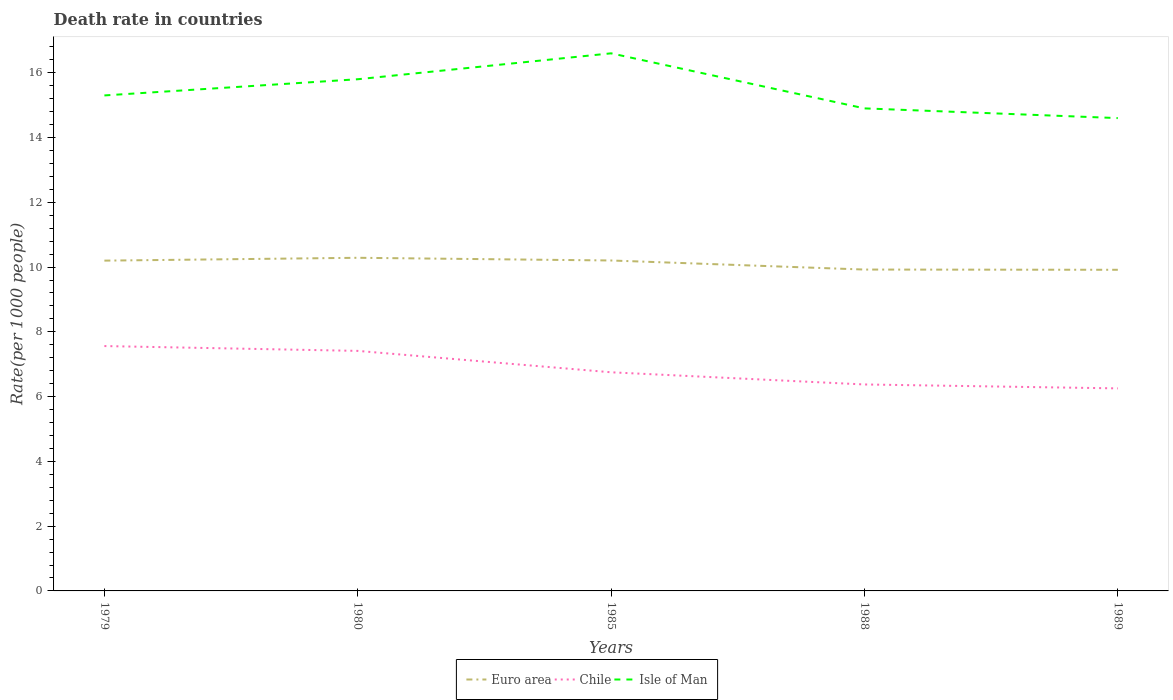How many different coloured lines are there?
Provide a short and direct response. 3. Does the line corresponding to Chile intersect with the line corresponding to Isle of Man?
Provide a succinct answer. No. In which year was the death rate in Euro area maximum?
Make the answer very short. 1989. What is the total death rate in Chile in the graph?
Ensure brevity in your answer.  1.04. What is the difference between the highest and the second highest death rate in Chile?
Your response must be concise. 1.31. What is the difference between two consecutive major ticks on the Y-axis?
Offer a very short reply. 2. Does the graph contain any zero values?
Provide a succinct answer. No. Does the graph contain grids?
Make the answer very short. No. Where does the legend appear in the graph?
Ensure brevity in your answer.  Bottom center. How are the legend labels stacked?
Your answer should be very brief. Horizontal. What is the title of the graph?
Give a very brief answer. Death rate in countries. Does "World" appear as one of the legend labels in the graph?
Give a very brief answer. No. What is the label or title of the X-axis?
Provide a short and direct response. Years. What is the label or title of the Y-axis?
Your answer should be compact. Rate(per 1000 people). What is the Rate(per 1000 people) of Euro area in 1979?
Offer a very short reply. 10.2. What is the Rate(per 1000 people) of Chile in 1979?
Your answer should be very brief. 7.56. What is the Rate(per 1000 people) in Isle of Man in 1979?
Provide a succinct answer. 15.3. What is the Rate(per 1000 people) in Euro area in 1980?
Keep it short and to the point. 10.29. What is the Rate(per 1000 people) in Chile in 1980?
Your answer should be compact. 7.41. What is the Rate(per 1000 people) of Isle of Man in 1980?
Provide a short and direct response. 15.8. What is the Rate(per 1000 people) of Euro area in 1985?
Keep it short and to the point. 10.2. What is the Rate(per 1000 people) in Chile in 1985?
Your response must be concise. 6.75. What is the Rate(per 1000 people) of Euro area in 1988?
Give a very brief answer. 9.92. What is the Rate(per 1000 people) of Chile in 1988?
Offer a very short reply. 6.38. What is the Rate(per 1000 people) of Isle of Man in 1988?
Keep it short and to the point. 14.9. What is the Rate(per 1000 people) in Euro area in 1989?
Give a very brief answer. 9.92. What is the Rate(per 1000 people) in Chile in 1989?
Provide a succinct answer. 6.25. Across all years, what is the maximum Rate(per 1000 people) of Euro area?
Provide a succinct answer. 10.29. Across all years, what is the maximum Rate(per 1000 people) in Chile?
Your answer should be compact. 7.56. Across all years, what is the maximum Rate(per 1000 people) of Isle of Man?
Offer a very short reply. 16.6. Across all years, what is the minimum Rate(per 1000 people) in Euro area?
Offer a terse response. 9.92. Across all years, what is the minimum Rate(per 1000 people) of Chile?
Your answer should be very brief. 6.25. Across all years, what is the minimum Rate(per 1000 people) in Isle of Man?
Keep it short and to the point. 14.6. What is the total Rate(per 1000 people) in Euro area in the graph?
Provide a succinct answer. 50.53. What is the total Rate(per 1000 people) in Chile in the graph?
Your answer should be very brief. 34.35. What is the total Rate(per 1000 people) of Isle of Man in the graph?
Offer a terse response. 77.2. What is the difference between the Rate(per 1000 people) in Euro area in 1979 and that in 1980?
Ensure brevity in your answer.  -0.09. What is the difference between the Rate(per 1000 people) in Chile in 1979 and that in 1980?
Ensure brevity in your answer.  0.15. What is the difference between the Rate(per 1000 people) in Euro area in 1979 and that in 1985?
Your answer should be very brief. -0. What is the difference between the Rate(per 1000 people) of Chile in 1979 and that in 1985?
Provide a succinct answer. 0.81. What is the difference between the Rate(per 1000 people) in Isle of Man in 1979 and that in 1985?
Your answer should be compact. -1.3. What is the difference between the Rate(per 1000 people) in Euro area in 1979 and that in 1988?
Offer a terse response. 0.28. What is the difference between the Rate(per 1000 people) in Chile in 1979 and that in 1988?
Ensure brevity in your answer.  1.19. What is the difference between the Rate(per 1000 people) in Euro area in 1979 and that in 1989?
Provide a succinct answer. 0.28. What is the difference between the Rate(per 1000 people) of Chile in 1979 and that in 1989?
Your answer should be compact. 1.31. What is the difference between the Rate(per 1000 people) in Isle of Man in 1979 and that in 1989?
Offer a terse response. 0.7. What is the difference between the Rate(per 1000 people) of Euro area in 1980 and that in 1985?
Give a very brief answer. 0.08. What is the difference between the Rate(per 1000 people) of Chile in 1980 and that in 1985?
Offer a terse response. 0.66. What is the difference between the Rate(per 1000 people) of Isle of Man in 1980 and that in 1985?
Your answer should be very brief. -0.8. What is the difference between the Rate(per 1000 people) in Euro area in 1980 and that in 1988?
Your answer should be very brief. 0.36. What is the difference between the Rate(per 1000 people) in Chile in 1980 and that in 1988?
Give a very brief answer. 1.04. What is the difference between the Rate(per 1000 people) in Euro area in 1980 and that in 1989?
Your response must be concise. 0.37. What is the difference between the Rate(per 1000 people) of Chile in 1980 and that in 1989?
Your answer should be very brief. 1.16. What is the difference between the Rate(per 1000 people) of Isle of Man in 1980 and that in 1989?
Offer a very short reply. 1.2. What is the difference between the Rate(per 1000 people) in Euro area in 1985 and that in 1988?
Offer a very short reply. 0.28. What is the difference between the Rate(per 1000 people) of Chile in 1985 and that in 1988?
Give a very brief answer. 0.38. What is the difference between the Rate(per 1000 people) of Euro area in 1985 and that in 1989?
Offer a terse response. 0.29. What is the difference between the Rate(per 1000 people) of Chile in 1985 and that in 1989?
Keep it short and to the point. 0.5. What is the difference between the Rate(per 1000 people) of Isle of Man in 1985 and that in 1989?
Provide a succinct answer. 2. What is the difference between the Rate(per 1000 people) of Euro area in 1988 and that in 1989?
Offer a terse response. 0.01. What is the difference between the Rate(per 1000 people) of Chile in 1988 and that in 1989?
Provide a short and direct response. 0.12. What is the difference between the Rate(per 1000 people) of Isle of Man in 1988 and that in 1989?
Provide a succinct answer. 0.3. What is the difference between the Rate(per 1000 people) in Euro area in 1979 and the Rate(per 1000 people) in Chile in 1980?
Keep it short and to the point. 2.79. What is the difference between the Rate(per 1000 people) of Euro area in 1979 and the Rate(per 1000 people) of Isle of Man in 1980?
Keep it short and to the point. -5.6. What is the difference between the Rate(per 1000 people) in Chile in 1979 and the Rate(per 1000 people) in Isle of Man in 1980?
Your answer should be very brief. -8.24. What is the difference between the Rate(per 1000 people) in Euro area in 1979 and the Rate(per 1000 people) in Chile in 1985?
Your answer should be very brief. 3.45. What is the difference between the Rate(per 1000 people) of Euro area in 1979 and the Rate(per 1000 people) of Isle of Man in 1985?
Provide a short and direct response. -6.4. What is the difference between the Rate(per 1000 people) in Chile in 1979 and the Rate(per 1000 people) in Isle of Man in 1985?
Keep it short and to the point. -9.04. What is the difference between the Rate(per 1000 people) in Euro area in 1979 and the Rate(per 1000 people) in Chile in 1988?
Your response must be concise. 3.82. What is the difference between the Rate(per 1000 people) in Euro area in 1979 and the Rate(per 1000 people) in Isle of Man in 1988?
Keep it short and to the point. -4.7. What is the difference between the Rate(per 1000 people) of Chile in 1979 and the Rate(per 1000 people) of Isle of Man in 1988?
Provide a short and direct response. -7.34. What is the difference between the Rate(per 1000 people) of Euro area in 1979 and the Rate(per 1000 people) of Chile in 1989?
Provide a succinct answer. 3.94. What is the difference between the Rate(per 1000 people) of Euro area in 1979 and the Rate(per 1000 people) of Isle of Man in 1989?
Offer a very short reply. -4.4. What is the difference between the Rate(per 1000 people) in Chile in 1979 and the Rate(per 1000 people) in Isle of Man in 1989?
Your answer should be compact. -7.04. What is the difference between the Rate(per 1000 people) in Euro area in 1980 and the Rate(per 1000 people) in Chile in 1985?
Your response must be concise. 3.54. What is the difference between the Rate(per 1000 people) in Euro area in 1980 and the Rate(per 1000 people) in Isle of Man in 1985?
Ensure brevity in your answer.  -6.31. What is the difference between the Rate(per 1000 people) in Chile in 1980 and the Rate(per 1000 people) in Isle of Man in 1985?
Your answer should be very brief. -9.19. What is the difference between the Rate(per 1000 people) of Euro area in 1980 and the Rate(per 1000 people) of Chile in 1988?
Your answer should be compact. 3.91. What is the difference between the Rate(per 1000 people) in Euro area in 1980 and the Rate(per 1000 people) in Isle of Man in 1988?
Your answer should be compact. -4.61. What is the difference between the Rate(per 1000 people) of Chile in 1980 and the Rate(per 1000 people) of Isle of Man in 1988?
Your answer should be very brief. -7.49. What is the difference between the Rate(per 1000 people) in Euro area in 1980 and the Rate(per 1000 people) in Chile in 1989?
Provide a succinct answer. 4.03. What is the difference between the Rate(per 1000 people) in Euro area in 1980 and the Rate(per 1000 people) in Isle of Man in 1989?
Keep it short and to the point. -4.31. What is the difference between the Rate(per 1000 people) of Chile in 1980 and the Rate(per 1000 people) of Isle of Man in 1989?
Provide a short and direct response. -7.19. What is the difference between the Rate(per 1000 people) of Euro area in 1985 and the Rate(per 1000 people) of Chile in 1988?
Your response must be concise. 3.83. What is the difference between the Rate(per 1000 people) in Euro area in 1985 and the Rate(per 1000 people) in Isle of Man in 1988?
Keep it short and to the point. -4.7. What is the difference between the Rate(per 1000 people) in Chile in 1985 and the Rate(per 1000 people) in Isle of Man in 1988?
Provide a short and direct response. -8.15. What is the difference between the Rate(per 1000 people) in Euro area in 1985 and the Rate(per 1000 people) in Chile in 1989?
Make the answer very short. 3.95. What is the difference between the Rate(per 1000 people) in Euro area in 1985 and the Rate(per 1000 people) in Isle of Man in 1989?
Keep it short and to the point. -4.4. What is the difference between the Rate(per 1000 people) of Chile in 1985 and the Rate(per 1000 people) of Isle of Man in 1989?
Provide a short and direct response. -7.85. What is the difference between the Rate(per 1000 people) of Euro area in 1988 and the Rate(per 1000 people) of Chile in 1989?
Offer a very short reply. 3.67. What is the difference between the Rate(per 1000 people) of Euro area in 1988 and the Rate(per 1000 people) of Isle of Man in 1989?
Keep it short and to the point. -4.68. What is the difference between the Rate(per 1000 people) of Chile in 1988 and the Rate(per 1000 people) of Isle of Man in 1989?
Keep it short and to the point. -8.22. What is the average Rate(per 1000 people) in Euro area per year?
Provide a succinct answer. 10.11. What is the average Rate(per 1000 people) of Chile per year?
Your response must be concise. 6.87. What is the average Rate(per 1000 people) in Isle of Man per year?
Offer a terse response. 15.44. In the year 1979, what is the difference between the Rate(per 1000 people) of Euro area and Rate(per 1000 people) of Chile?
Your answer should be very brief. 2.64. In the year 1979, what is the difference between the Rate(per 1000 people) in Euro area and Rate(per 1000 people) in Isle of Man?
Provide a succinct answer. -5.1. In the year 1979, what is the difference between the Rate(per 1000 people) of Chile and Rate(per 1000 people) of Isle of Man?
Your response must be concise. -7.74. In the year 1980, what is the difference between the Rate(per 1000 people) of Euro area and Rate(per 1000 people) of Chile?
Provide a succinct answer. 2.87. In the year 1980, what is the difference between the Rate(per 1000 people) in Euro area and Rate(per 1000 people) in Isle of Man?
Keep it short and to the point. -5.51. In the year 1980, what is the difference between the Rate(per 1000 people) of Chile and Rate(per 1000 people) of Isle of Man?
Make the answer very short. -8.39. In the year 1985, what is the difference between the Rate(per 1000 people) in Euro area and Rate(per 1000 people) in Chile?
Offer a very short reply. 3.45. In the year 1985, what is the difference between the Rate(per 1000 people) of Euro area and Rate(per 1000 people) of Isle of Man?
Make the answer very short. -6.4. In the year 1985, what is the difference between the Rate(per 1000 people) in Chile and Rate(per 1000 people) in Isle of Man?
Provide a succinct answer. -9.85. In the year 1988, what is the difference between the Rate(per 1000 people) of Euro area and Rate(per 1000 people) of Chile?
Provide a succinct answer. 3.55. In the year 1988, what is the difference between the Rate(per 1000 people) of Euro area and Rate(per 1000 people) of Isle of Man?
Offer a very short reply. -4.98. In the year 1988, what is the difference between the Rate(per 1000 people) of Chile and Rate(per 1000 people) of Isle of Man?
Your answer should be very brief. -8.53. In the year 1989, what is the difference between the Rate(per 1000 people) in Euro area and Rate(per 1000 people) in Chile?
Offer a terse response. 3.66. In the year 1989, what is the difference between the Rate(per 1000 people) of Euro area and Rate(per 1000 people) of Isle of Man?
Provide a succinct answer. -4.68. In the year 1989, what is the difference between the Rate(per 1000 people) in Chile and Rate(per 1000 people) in Isle of Man?
Make the answer very short. -8.35. What is the ratio of the Rate(per 1000 people) in Euro area in 1979 to that in 1980?
Offer a terse response. 0.99. What is the ratio of the Rate(per 1000 people) of Chile in 1979 to that in 1980?
Offer a very short reply. 1.02. What is the ratio of the Rate(per 1000 people) of Isle of Man in 1979 to that in 1980?
Your answer should be very brief. 0.97. What is the ratio of the Rate(per 1000 people) in Euro area in 1979 to that in 1985?
Offer a terse response. 1. What is the ratio of the Rate(per 1000 people) of Chile in 1979 to that in 1985?
Offer a terse response. 1.12. What is the ratio of the Rate(per 1000 people) in Isle of Man in 1979 to that in 1985?
Your answer should be compact. 0.92. What is the ratio of the Rate(per 1000 people) of Euro area in 1979 to that in 1988?
Your answer should be very brief. 1.03. What is the ratio of the Rate(per 1000 people) in Chile in 1979 to that in 1988?
Your answer should be compact. 1.19. What is the ratio of the Rate(per 1000 people) of Isle of Man in 1979 to that in 1988?
Ensure brevity in your answer.  1.03. What is the ratio of the Rate(per 1000 people) of Euro area in 1979 to that in 1989?
Offer a very short reply. 1.03. What is the ratio of the Rate(per 1000 people) in Chile in 1979 to that in 1989?
Ensure brevity in your answer.  1.21. What is the ratio of the Rate(per 1000 people) of Isle of Man in 1979 to that in 1989?
Provide a short and direct response. 1.05. What is the ratio of the Rate(per 1000 people) of Euro area in 1980 to that in 1985?
Provide a succinct answer. 1.01. What is the ratio of the Rate(per 1000 people) in Chile in 1980 to that in 1985?
Offer a very short reply. 1.1. What is the ratio of the Rate(per 1000 people) in Isle of Man in 1980 to that in 1985?
Your answer should be compact. 0.95. What is the ratio of the Rate(per 1000 people) in Euro area in 1980 to that in 1988?
Offer a terse response. 1.04. What is the ratio of the Rate(per 1000 people) in Chile in 1980 to that in 1988?
Keep it short and to the point. 1.16. What is the ratio of the Rate(per 1000 people) in Isle of Man in 1980 to that in 1988?
Your answer should be very brief. 1.06. What is the ratio of the Rate(per 1000 people) of Euro area in 1980 to that in 1989?
Your answer should be compact. 1.04. What is the ratio of the Rate(per 1000 people) in Chile in 1980 to that in 1989?
Your answer should be compact. 1.19. What is the ratio of the Rate(per 1000 people) in Isle of Man in 1980 to that in 1989?
Offer a terse response. 1.08. What is the ratio of the Rate(per 1000 people) of Euro area in 1985 to that in 1988?
Your answer should be compact. 1.03. What is the ratio of the Rate(per 1000 people) of Chile in 1985 to that in 1988?
Your answer should be compact. 1.06. What is the ratio of the Rate(per 1000 people) in Isle of Man in 1985 to that in 1988?
Ensure brevity in your answer.  1.11. What is the ratio of the Rate(per 1000 people) of Euro area in 1985 to that in 1989?
Provide a short and direct response. 1.03. What is the ratio of the Rate(per 1000 people) of Chile in 1985 to that in 1989?
Provide a short and direct response. 1.08. What is the ratio of the Rate(per 1000 people) in Isle of Man in 1985 to that in 1989?
Your answer should be compact. 1.14. What is the ratio of the Rate(per 1000 people) of Chile in 1988 to that in 1989?
Make the answer very short. 1.02. What is the ratio of the Rate(per 1000 people) in Isle of Man in 1988 to that in 1989?
Offer a terse response. 1.02. What is the difference between the highest and the second highest Rate(per 1000 people) in Euro area?
Keep it short and to the point. 0.08. What is the difference between the highest and the second highest Rate(per 1000 people) in Chile?
Offer a very short reply. 0.15. What is the difference between the highest and the lowest Rate(per 1000 people) in Euro area?
Your response must be concise. 0.37. What is the difference between the highest and the lowest Rate(per 1000 people) in Chile?
Provide a short and direct response. 1.31. 